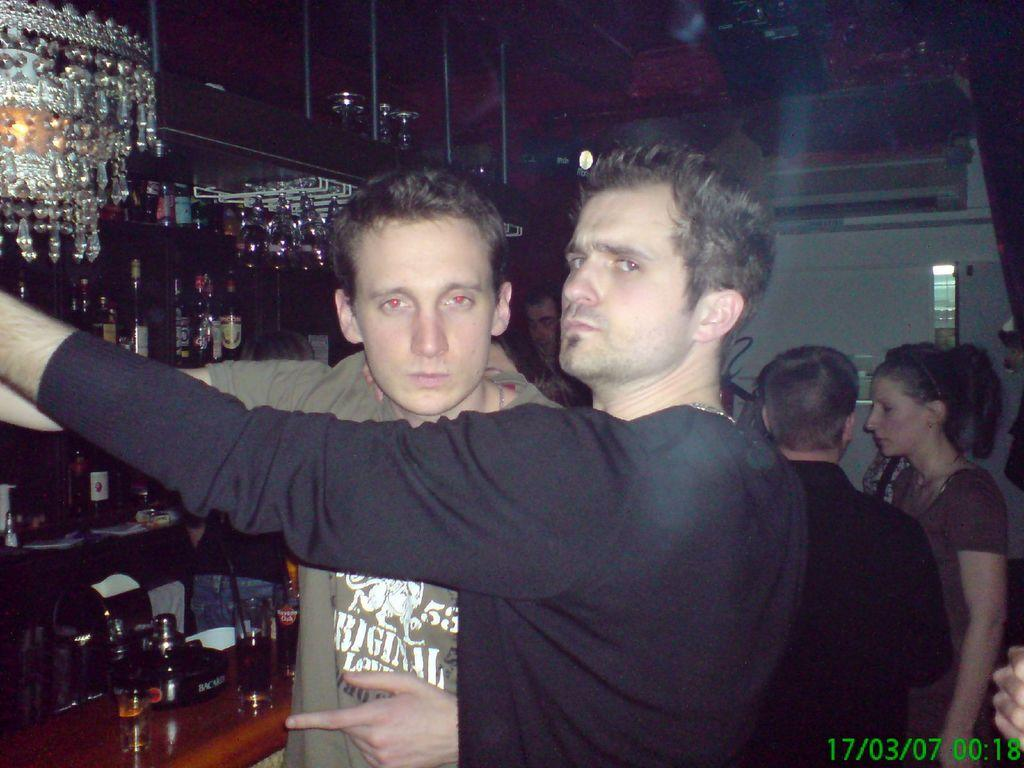Who or what can be seen in the image? There are people in the image. What objects related to beverages are present in the image? There are bottles on racks and glasses in the image. Can you describe the location of a specific bottle in the image? There is a bottle on a table in the image. What type of lighting fixture is visible in the image? There is a chandelier in the image. What architectural feature can be seen in the image? There is a wall in the image. In which direction are the ants moving in the image? There are no ants present in the image. What year is depicted in the image? The image does not depict a specific year; it is a still image without any temporal context. 